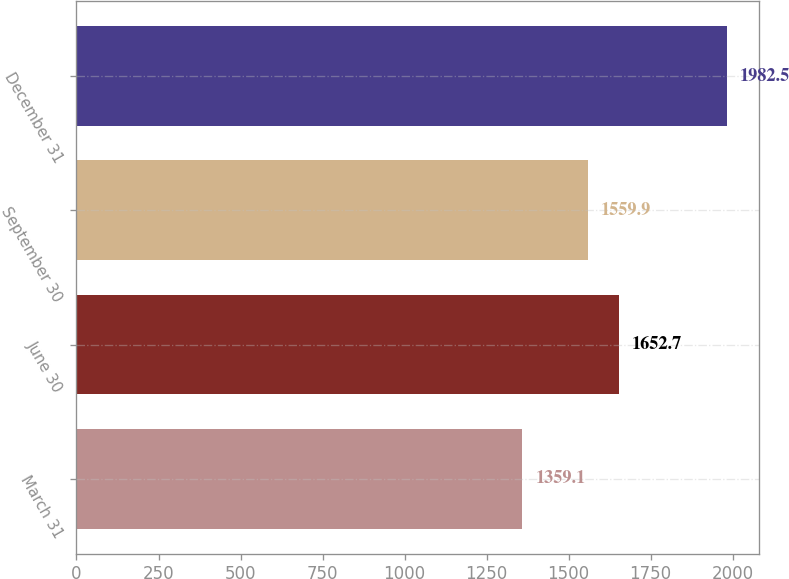Convert chart to OTSL. <chart><loc_0><loc_0><loc_500><loc_500><bar_chart><fcel>March 31<fcel>June 30<fcel>September 30<fcel>December 31<nl><fcel>1359.1<fcel>1652.7<fcel>1559.9<fcel>1982.5<nl></chart> 